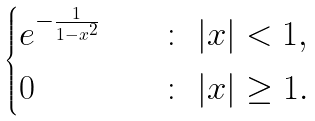<formula> <loc_0><loc_0><loc_500><loc_500>\begin{cases} e ^ { - \frac { 1 } { 1 - x ^ { 2 } } } \quad & \colon \ | x | < 1 , \\ 0 \quad & \colon \ | x | \geq 1 . \end{cases}</formula> 